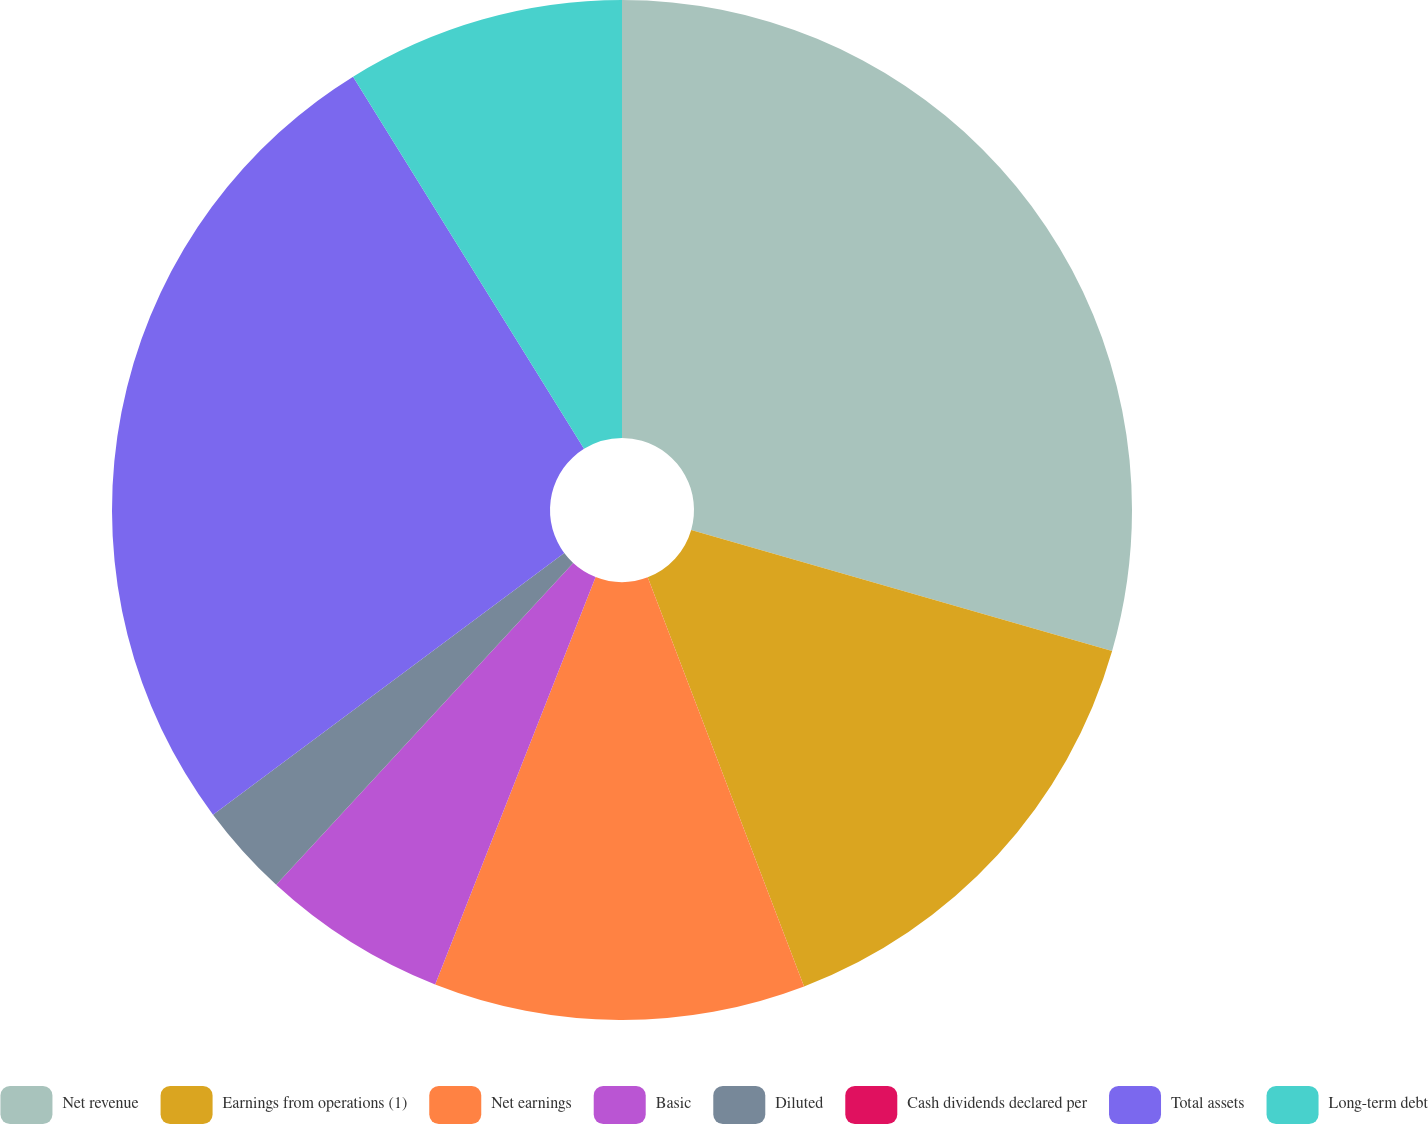Convert chart. <chart><loc_0><loc_0><loc_500><loc_500><pie_chart><fcel>Net revenue<fcel>Earnings from operations (1)<fcel>Net earnings<fcel>Basic<fcel>Diluted<fcel>Cash dividends declared per<fcel>Total assets<fcel>Long-term debt<nl><fcel>29.46%<fcel>14.73%<fcel>11.78%<fcel>5.89%<fcel>2.95%<fcel>0.0%<fcel>26.35%<fcel>8.84%<nl></chart> 